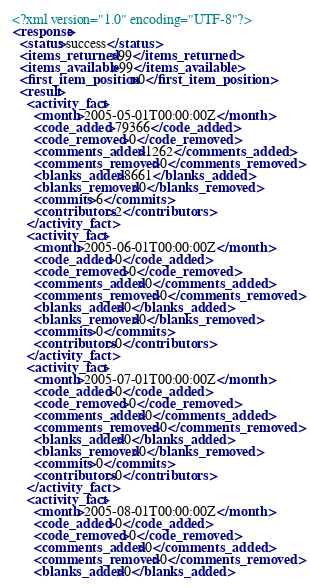Convert code to text. <code><loc_0><loc_0><loc_500><loc_500><_XML_><?xml version="1.0" encoding="UTF-8"?>
<response>
  <status>success</status>
  <items_returned>99</items_returned>
  <items_available>99</items_available>
  <first_item_position>0</first_item_position>
  <result>
    <activity_fact>
      <month>2005-05-01T00:00:00Z</month>
      <code_added>79366</code_added>
      <code_removed>0</code_removed>
      <comments_added>1262</comments_added>
      <comments_removed>0</comments_removed>
      <blanks_added>8661</blanks_added>
      <blanks_removed>0</blanks_removed>
      <commits>6</commits>
      <contributors>2</contributors>
    </activity_fact>
    <activity_fact>
      <month>2005-06-01T00:00:00Z</month>
      <code_added>0</code_added>
      <code_removed>0</code_removed>
      <comments_added>0</comments_added>
      <comments_removed>0</comments_removed>
      <blanks_added>0</blanks_added>
      <blanks_removed>0</blanks_removed>
      <commits>0</commits>
      <contributors>0</contributors>
    </activity_fact>
    <activity_fact>
      <month>2005-07-01T00:00:00Z</month>
      <code_added>0</code_added>
      <code_removed>0</code_removed>
      <comments_added>0</comments_added>
      <comments_removed>0</comments_removed>
      <blanks_added>0</blanks_added>
      <blanks_removed>0</blanks_removed>
      <commits>0</commits>
      <contributors>0</contributors>
    </activity_fact>
    <activity_fact>
      <month>2005-08-01T00:00:00Z</month>
      <code_added>0</code_added>
      <code_removed>0</code_removed>
      <comments_added>0</comments_added>
      <comments_removed>0</comments_removed>
      <blanks_added>0</blanks_added></code> 